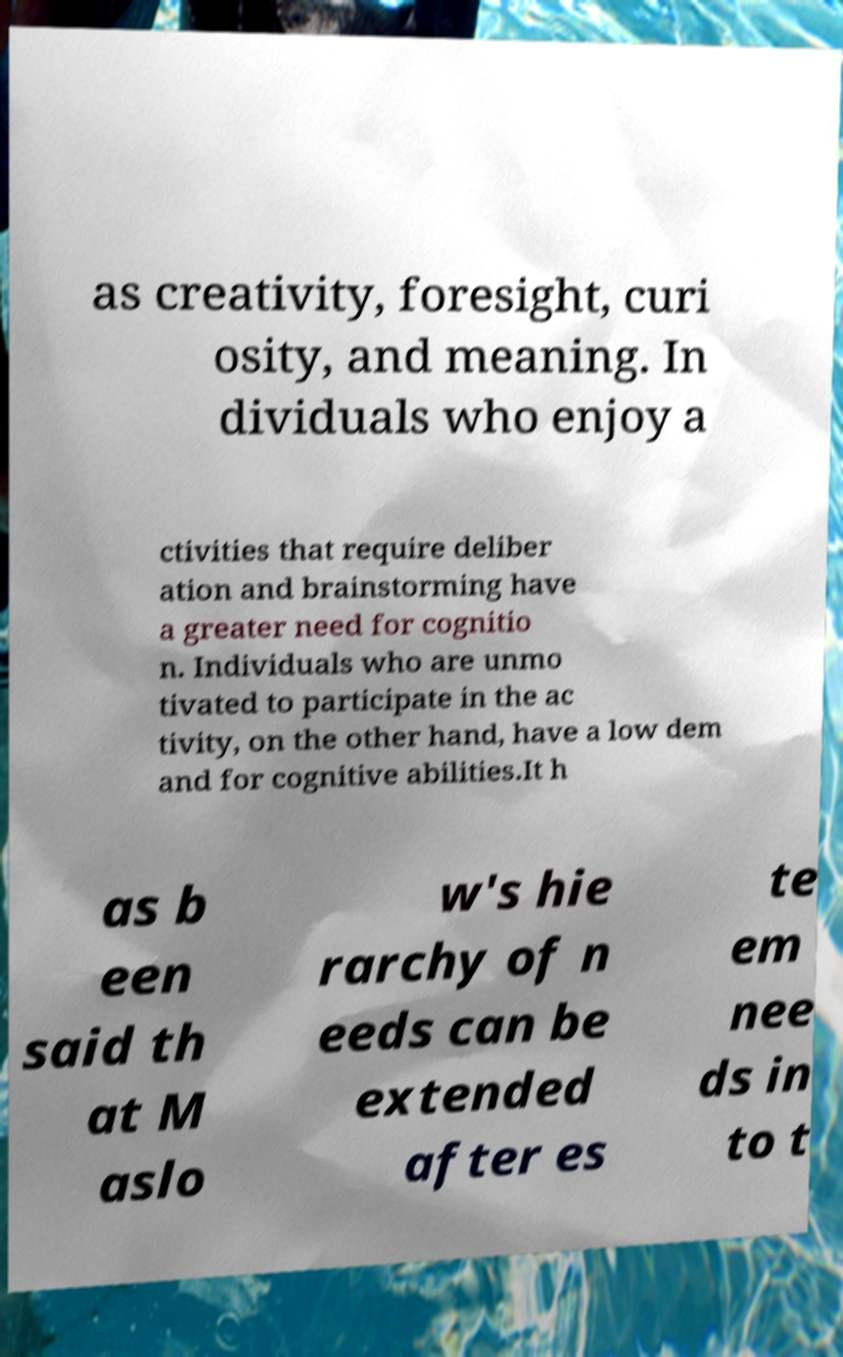I need the written content from this picture converted into text. Can you do that? as creativity, foresight, curi osity, and meaning. In dividuals who enjoy a ctivities that require deliber ation and brainstorming have a greater need for cognitio n. Individuals who are unmo tivated to participate in the ac tivity, on the other hand, have a low dem and for cognitive abilities.It h as b een said th at M aslo w's hie rarchy of n eeds can be extended after es te em nee ds in to t 